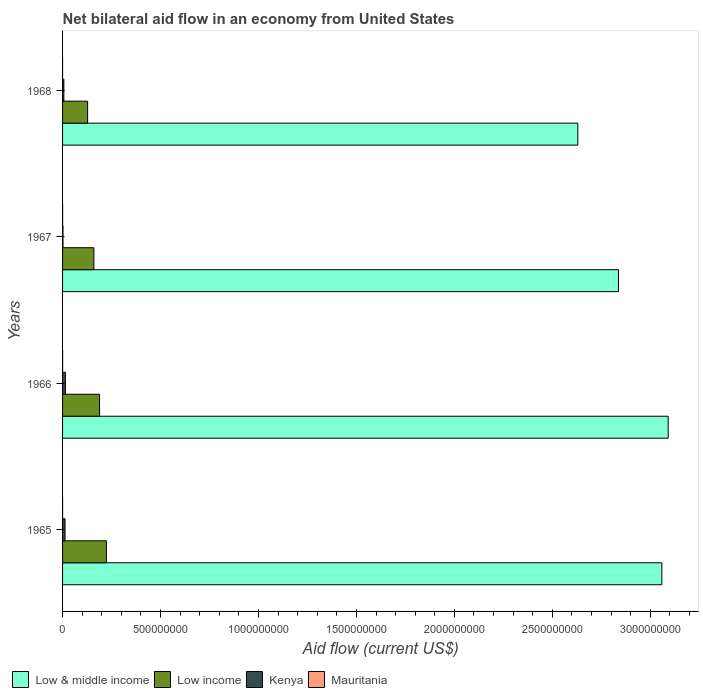Are the number of bars per tick equal to the number of legend labels?
Your answer should be compact. Yes. Are the number of bars on each tick of the Y-axis equal?
Make the answer very short. Yes. How many bars are there on the 2nd tick from the top?
Offer a very short reply. 4. What is the label of the 2nd group of bars from the top?
Your answer should be very brief. 1967. What is the net bilateral aid flow in Kenya in 1966?
Offer a terse response. 1.45e+07. Across all years, what is the minimum net bilateral aid flow in Low income?
Provide a short and direct response. 1.28e+08. In which year was the net bilateral aid flow in Mauritania maximum?
Offer a very short reply. 1966. In which year was the net bilateral aid flow in Low income minimum?
Your answer should be very brief. 1968. What is the total net bilateral aid flow in Low income in the graph?
Make the answer very short. 7.00e+08. What is the difference between the net bilateral aid flow in Mauritania in 1965 and the net bilateral aid flow in Low & middle income in 1968?
Offer a terse response. -2.63e+09. What is the average net bilateral aid flow in Kenya per year?
Your answer should be very brief. 8.94e+06. In the year 1965, what is the difference between the net bilateral aid flow in Kenya and net bilateral aid flow in Mauritania?
Your answer should be very brief. 1.25e+07. What is the ratio of the net bilateral aid flow in Kenya in 1967 to that in 1968?
Give a very brief answer. 0.32. Is the net bilateral aid flow in Mauritania in 1966 less than that in 1968?
Your response must be concise. No. Is the difference between the net bilateral aid flow in Kenya in 1965 and 1967 greater than the difference between the net bilateral aid flow in Mauritania in 1965 and 1967?
Provide a short and direct response. Yes. What is the difference between the highest and the second highest net bilateral aid flow in Low & middle income?
Your answer should be compact. 3.24e+07. What is the difference between the highest and the lowest net bilateral aid flow in Low & middle income?
Your answer should be very brief. 4.61e+08. Is the sum of the net bilateral aid flow in Low & middle income in 1966 and 1968 greater than the maximum net bilateral aid flow in Kenya across all years?
Your answer should be very brief. Yes. What does the 2nd bar from the top in 1965 represents?
Keep it short and to the point. Kenya. What does the 4th bar from the bottom in 1967 represents?
Offer a very short reply. Mauritania. How many bars are there?
Give a very brief answer. 16. Are all the bars in the graph horizontal?
Give a very brief answer. Yes. Does the graph contain grids?
Your answer should be very brief. No. Where does the legend appear in the graph?
Give a very brief answer. Bottom left. How are the legend labels stacked?
Offer a very short reply. Horizontal. What is the title of the graph?
Provide a succinct answer. Net bilateral aid flow in an economy from United States. Does "Bulgaria" appear as one of the legend labels in the graph?
Provide a succinct answer. No. What is the Aid flow (current US$) of Low & middle income in 1965?
Ensure brevity in your answer.  3.06e+09. What is the Aid flow (current US$) of Low income in 1965?
Offer a terse response. 2.24e+08. What is the Aid flow (current US$) in Kenya in 1965?
Provide a short and direct response. 1.26e+07. What is the Aid flow (current US$) in Mauritania in 1965?
Your response must be concise. 1.30e+05. What is the Aid flow (current US$) of Low & middle income in 1966?
Offer a terse response. 3.09e+09. What is the Aid flow (current US$) in Low income in 1966?
Ensure brevity in your answer.  1.89e+08. What is the Aid flow (current US$) in Kenya in 1966?
Give a very brief answer. 1.45e+07. What is the Aid flow (current US$) of Mauritania in 1966?
Offer a very short reply. 3.40e+05. What is the Aid flow (current US$) of Low & middle income in 1967?
Keep it short and to the point. 2.84e+09. What is the Aid flow (current US$) of Low income in 1967?
Provide a short and direct response. 1.60e+08. What is the Aid flow (current US$) in Kenya in 1967?
Your answer should be very brief. 2.10e+06. What is the Aid flow (current US$) in Mauritania in 1967?
Ensure brevity in your answer.  2.70e+05. What is the Aid flow (current US$) in Low & middle income in 1968?
Provide a succinct answer. 2.63e+09. What is the Aid flow (current US$) in Low income in 1968?
Offer a terse response. 1.28e+08. What is the Aid flow (current US$) of Kenya in 1968?
Offer a very short reply. 6.58e+06. What is the Aid flow (current US$) of Mauritania in 1968?
Offer a terse response. 2.00e+04. Across all years, what is the maximum Aid flow (current US$) of Low & middle income?
Offer a very short reply. 3.09e+09. Across all years, what is the maximum Aid flow (current US$) in Low income?
Make the answer very short. 2.24e+08. Across all years, what is the maximum Aid flow (current US$) of Kenya?
Provide a succinct answer. 1.45e+07. Across all years, what is the maximum Aid flow (current US$) of Mauritania?
Offer a terse response. 3.40e+05. Across all years, what is the minimum Aid flow (current US$) of Low & middle income?
Offer a very short reply. 2.63e+09. Across all years, what is the minimum Aid flow (current US$) in Low income?
Provide a short and direct response. 1.28e+08. Across all years, what is the minimum Aid flow (current US$) in Kenya?
Offer a very short reply. 2.10e+06. What is the total Aid flow (current US$) in Low & middle income in the graph?
Keep it short and to the point. 1.16e+1. What is the total Aid flow (current US$) in Low income in the graph?
Your answer should be compact. 7.00e+08. What is the total Aid flow (current US$) in Kenya in the graph?
Your answer should be very brief. 3.58e+07. What is the total Aid flow (current US$) of Mauritania in the graph?
Give a very brief answer. 7.60e+05. What is the difference between the Aid flow (current US$) in Low & middle income in 1965 and that in 1966?
Ensure brevity in your answer.  -3.24e+07. What is the difference between the Aid flow (current US$) in Low income in 1965 and that in 1966?
Your answer should be very brief. 3.49e+07. What is the difference between the Aid flow (current US$) in Kenya in 1965 and that in 1966?
Offer a terse response. -1.84e+06. What is the difference between the Aid flow (current US$) of Low & middle income in 1965 and that in 1967?
Provide a short and direct response. 2.21e+08. What is the difference between the Aid flow (current US$) of Low income in 1965 and that in 1967?
Offer a terse response. 6.38e+07. What is the difference between the Aid flow (current US$) of Kenya in 1965 and that in 1967?
Ensure brevity in your answer.  1.05e+07. What is the difference between the Aid flow (current US$) of Low & middle income in 1965 and that in 1968?
Ensure brevity in your answer.  4.29e+08. What is the difference between the Aid flow (current US$) of Low income in 1965 and that in 1968?
Give a very brief answer. 9.59e+07. What is the difference between the Aid flow (current US$) of Kenya in 1965 and that in 1968?
Provide a short and direct response. 6.04e+06. What is the difference between the Aid flow (current US$) in Mauritania in 1965 and that in 1968?
Offer a terse response. 1.10e+05. What is the difference between the Aid flow (current US$) of Low & middle income in 1966 and that in 1967?
Offer a very short reply. 2.54e+08. What is the difference between the Aid flow (current US$) in Low income in 1966 and that in 1967?
Offer a terse response. 2.89e+07. What is the difference between the Aid flow (current US$) in Kenya in 1966 and that in 1967?
Give a very brief answer. 1.24e+07. What is the difference between the Aid flow (current US$) in Low & middle income in 1966 and that in 1968?
Offer a very short reply. 4.61e+08. What is the difference between the Aid flow (current US$) in Low income in 1966 and that in 1968?
Give a very brief answer. 6.10e+07. What is the difference between the Aid flow (current US$) of Kenya in 1966 and that in 1968?
Give a very brief answer. 7.88e+06. What is the difference between the Aid flow (current US$) in Mauritania in 1966 and that in 1968?
Give a very brief answer. 3.20e+05. What is the difference between the Aid flow (current US$) in Low & middle income in 1967 and that in 1968?
Give a very brief answer. 2.08e+08. What is the difference between the Aid flow (current US$) in Low income in 1967 and that in 1968?
Keep it short and to the point. 3.21e+07. What is the difference between the Aid flow (current US$) of Kenya in 1967 and that in 1968?
Your answer should be compact. -4.48e+06. What is the difference between the Aid flow (current US$) in Mauritania in 1967 and that in 1968?
Ensure brevity in your answer.  2.50e+05. What is the difference between the Aid flow (current US$) of Low & middle income in 1965 and the Aid flow (current US$) of Low income in 1966?
Your answer should be very brief. 2.87e+09. What is the difference between the Aid flow (current US$) of Low & middle income in 1965 and the Aid flow (current US$) of Kenya in 1966?
Offer a terse response. 3.04e+09. What is the difference between the Aid flow (current US$) of Low & middle income in 1965 and the Aid flow (current US$) of Mauritania in 1966?
Your answer should be very brief. 3.06e+09. What is the difference between the Aid flow (current US$) in Low income in 1965 and the Aid flow (current US$) in Kenya in 1966?
Provide a succinct answer. 2.09e+08. What is the difference between the Aid flow (current US$) of Low income in 1965 and the Aid flow (current US$) of Mauritania in 1966?
Offer a terse response. 2.23e+08. What is the difference between the Aid flow (current US$) in Kenya in 1965 and the Aid flow (current US$) in Mauritania in 1966?
Keep it short and to the point. 1.23e+07. What is the difference between the Aid flow (current US$) in Low & middle income in 1965 and the Aid flow (current US$) in Low income in 1967?
Your response must be concise. 2.90e+09. What is the difference between the Aid flow (current US$) of Low & middle income in 1965 and the Aid flow (current US$) of Kenya in 1967?
Provide a succinct answer. 3.06e+09. What is the difference between the Aid flow (current US$) of Low & middle income in 1965 and the Aid flow (current US$) of Mauritania in 1967?
Offer a terse response. 3.06e+09. What is the difference between the Aid flow (current US$) in Low income in 1965 and the Aid flow (current US$) in Kenya in 1967?
Ensure brevity in your answer.  2.22e+08. What is the difference between the Aid flow (current US$) of Low income in 1965 and the Aid flow (current US$) of Mauritania in 1967?
Make the answer very short. 2.24e+08. What is the difference between the Aid flow (current US$) in Kenya in 1965 and the Aid flow (current US$) in Mauritania in 1967?
Keep it short and to the point. 1.24e+07. What is the difference between the Aid flow (current US$) of Low & middle income in 1965 and the Aid flow (current US$) of Low income in 1968?
Provide a short and direct response. 2.93e+09. What is the difference between the Aid flow (current US$) of Low & middle income in 1965 and the Aid flow (current US$) of Kenya in 1968?
Keep it short and to the point. 3.05e+09. What is the difference between the Aid flow (current US$) of Low & middle income in 1965 and the Aid flow (current US$) of Mauritania in 1968?
Provide a short and direct response. 3.06e+09. What is the difference between the Aid flow (current US$) of Low income in 1965 and the Aid flow (current US$) of Kenya in 1968?
Give a very brief answer. 2.17e+08. What is the difference between the Aid flow (current US$) in Low income in 1965 and the Aid flow (current US$) in Mauritania in 1968?
Keep it short and to the point. 2.24e+08. What is the difference between the Aid flow (current US$) in Kenya in 1965 and the Aid flow (current US$) in Mauritania in 1968?
Your answer should be compact. 1.26e+07. What is the difference between the Aid flow (current US$) in Low & middle income in 1966 and the Aid flow (current US$) in Low income in 1967?
Keep it short and to the point. 2.93e+09. What is the difference between the Aid flow (current US$) of Low & middle income in 1966 and the Aid flow (current US$) of Kenya in 1967?
Offer a very short reply. 3.09e+09. What is the difference between the Aid flow (current US$) in Low & middle income in 1966 and the Aid flow (current US$) in Mauritania in 1967?
Give a very brief answer. 3.09e+09. What is the difference between the Aid flow (current US$) of Low income in 1966 and the Aid flow (current US$) of Kenya in 1967?
Your answer should be very brief. 1.87e+08. What is the difference between the Aid flow (current US$) in Low income in 1966 and the Aid flow (current US$) in Mauritania in 1967?
Provide a succinct answer. 1.89e+08. What is the difference between the Aid flow (current US$) of Kenya in 1966 and the Aid flow (current US$) of Mauritania in 1967?
Your response must be concise. 1.42e+07. What is the difference between the Aid flow (current US$) of Low & middle income in 1966 and the Aid flow (current US$) of Low income in 1968?
Offer a terse response. 2.96e+09. What is the difference between the Aid flow (current US$) of Low & middle income in 1966 and the Aid flow (current US$) of Kenya in 1968?
Offer a very short reply. 3.08e+09. What is the difference between the Aid flow (current US$) of Low & middle income in 1966 and the Aid flow (current US$) of Mauritania in 1968?
Ensure brevity in your answer.  3.09e+09. What is the difference between the Aid flow (current US$) of Low income in 1966 and the Aid flow (current US$) of Kenya in 1968?
Provide a succinct answer. 1.82e+08. What is the difference between the Aid flow (current US$) in Low income in 1966 and the Aid flow (current US$) in Mauritania in 1968?
Offer a very short reply. 1.89e+08. What is the difference between the Aid flow (current US$) in Kenya in 1966 and the Aid flow (current US$) in Mauritania in 1968?
Your response must be concise. 1.44e+07. What is the difference between the Aid flow (current US$) in Low & middle income in 1967 and the Aid flow (current US$) in Low income in 1968?
Ensure brevity in your answer.  2.71e+09. What is the difference between the Aid flow (current US$) of Low & middle income in 1967 and the Aid flow (current US$) of Kenya in 1968?
Ensure brevity in your answer.  2.83e+09. What is the difference between the Aid flow (current US$) of Low & middle income in 1967 and the Aid flow (current US$) of Mauritania in 1968?
Provide a short and direct response. 2.84e+09. What is the difference between the Aid flow (current US$) in Low income in 1967 and the Aid flow (current US$) in Kenya in 1968?
Offer a very short reply. 1.53e+08. What is the difference between the Aid flow (current US$) of Low income in 1967 and the Aid flow (current US$) of Mauritania in 1968?
Ensure brevity in your answer.  1.60e+08. What is the difference between the Aid flow (current US$) of Kenya in 1967 and the Aid flow (current US$) of Mauritania in 1968?
Your answer should be very brief. 2.08e+06. What is the average Aid flow (current US$) of Low & middle income per year?
Keep it short and to the point. 2.90e+09. What is the average Aid flow (current US$) in Low income per year?
Your response must be concise. 1.75e+08. What is the average Aid flow (current US$) in Kenya per year?
Provide a short and direct response. 8.94e+06. In the year 1965, what is the difference between the Aid flow (current US$) of Low & middle income and Aid flow (current US$) of Low income?
Your answer should be compact. 2.84e+09. In the year 1965, what is the difference between the Aid flow (current US$) in Low & middle income and Aid flow (current US$) in Kenya?
Provide a succinct answer. 3.05e+09. In the year 1965, what is the difference between the Aid flow (current US$) in Low & middle income and Aid flow (current US$) in Mauritania?
Your answer should be compact. 3.06e+09. In the year 1965, what is the difference between the Aid flow (current US$) in Low income and Aid flow (current US$) in Kenya?
Ensure brevity in your answer.  2.11e+08. In the year 1965, what is the difference between the Aid flow (current US$) of Low income and Aid flow (current US$) of Mauritania?
Ensure brevity in your answer.  2.24e+08. In the year 1965, what is the difference between the Aid flow (current US$) in Kenya and Aid flow (current US$) in Mauritania?
Give a very brief answer. 1.25e+07. In the year 1966, what is the difference between the Aid flow (current US$) of Low & middle income and Aid flow (current US$) of Low income?
Keep it short and to the point. 2.90e+09. In the year 1966, what is the difference between the Aid flow (current US$) in Low & middle income and Aid flow (current US$) in Kenya?
Offer a very short reply. 3.08e+09. In the year 1966, what is the difference between the Aid flow (current US$) in Low & middle income and Aid flow (current US$) in Mauritania?
Make the answer very short. 3.09e+09. In the year 1966, what is the difference between the Aid flow (current US$) of Low income and Aid flow (current US$) of Kenya?
Keep it short and to the point. 1.74e+08. In the year 1966, what is the difference between the Aid flow (current US$) of Low income and Aid flow (current US$) of Mauritania?
Your answer should be very brief. 1.89e+08. In the year 1966, what is the difference between the Aid flow (current US$) in Kenya and Aid flow (current US$) in Mauritania?
Make the answer very short. 1.41e+07. In the year 1967, what is the difference between the Aid flow (current US$) of Low & middle income and Aid flow (current US$) of Low income?
Provide a succinct answer. 2.68e+09. In the year 1967, what is the difference between the Aid flow (current US$) in Low & middle income and Aid flow (current US$) in Kenya?
Your response must be concise. 2.84e+09. In the year 1967, what is the difference between the Aid flow (current US$) of Low & middle income and Aid flow (current US$) of Mauritania?
Ensure brevity in your answer.  2.84e+09. In the year 1967, what is the difference between the Aid flow (current US$) of Low income and Aid flow (current US$) of Kenya?
Offer a terse response. 1.58e+08. In the year 1967, what is the difference between the Aid flow (current US$) of Low income and Aid flow (current US$) of Mauritania?
Provide a short and direct response. 1.60e+08. In the year 1967, what is the difference between the Aid flow (current US$) of Kenya and Aid flow (current US$) of Mauritania?
Provide a short and direct response. 1.83e+06. In the year 1968, what is the difference between the Aid flow (current US$) of Low & middle income and Aid flow (current US$) of Low income?
Offer a very short reply. 2.50e+09. In the year 1968, what is the difference between the Aid flow (current US$) of Low & middle income and Aid flow (current US$) of Kenya?
Provide a succinct answer. 2.62e+09. In the year 1968, what is the difference between the Aid flow (current US$) of Low & middle income and Aid flow (current US$) of Mauritania?
Provide a succinct answer. 2.63e+09. In the year 1968, what is the difference between the Aid flow (current US$) in Low income and Aid flow (current US$) in Kenya?
Provide a succinct answer. 1.21e+08. In the year 1968, what is the difference between the Aid flow (current US$) of Low income and Aid flow (current US$) of Mauritania?
Your answer should be compact. 1.28e+08. In the year 1968, what is the difference between the Aid flow (current US$) of Kenya and Aid flow (current US$) of Mauritania?
Your answer should be very brief. 6.56e+06. What is the ratio of the Aid flow (current US$) in Low & middle income in 1965 to that in 1966?
Offer a very short reply. 0.99. What is the ratio of the Aid flow (current US$) of Low income in 1965 to that in 1966?
Provide a succinct answer. 1.18. What is the ratio of the Aid flow (current US$) of Kenya in 1965 to that in 1966?
Keep it short and to the point. 0.87. What is the ratio of the Aid flow (current US$) in Mauritania in 1965 to that in 1966?
Offer a terse response. 0.38. What is the ratio of the Aid flow (current US$) of Low & middle income in 1965 to that in 1967?
Offer a very short reply. 1.08. What is the ratio of the Aid flow (current US$) of Low income in 1965 to that in 1967?
Make the answer very short. 1.4. What is the ratio of the Aid flow (current US$) of Kenya in 1965 to that in 1967?
Ensure brevity in your answer.  6.01. What is the ratio of the Aid flow (current US$) in Mauritania in 1965 to that in 1967?
Your response must be concise. 0.48. What is the ratio of the Aid flow (current US$) in Low & middle income in 1965 to that in 1968?
Make the answer very short. 1.16. What is the ratio of the Aid flow (current US$) in Low income in 1965 to that in 1968?
Provide a short and direct response. 1.75. What is the ratio of the Aid flow (current US$) of Kenya in 1965 to that in 1968?
Offer a terse response. 1.92. What is the ratio of the Aid flow (current US$) of Mauritania in 1965 to that in 1968?
Your response must be concise. 6.5. What is the ratio of the Aid flow (current US$) of Low & middle income in 1966 to that in 1967?
Offer a terse response. 1.09. What is the ratio of the Aid flow (current US$) in Low income in 1966 to that in 1967?
Offer a terse response. 1.18. What is the ratio of the Aid flow (current US$) of Kenya in 1966 to that in 1967?
Your response must be concise. 6.89. What is the ratio of the Aid flow (current US$) of Mauritania in 1966 to that in 1967?
Offer a very short reply. 1.26. What is the ratio of the Aid flow (current US$) in Low & middle income in 1966 to that in 1968?
Offer a terse response. 1.18. What is the ratio of the Aid flow (current US$) in Low income in 1966 to that in 1968?
Your answer should be compact. 1.48. What is the ratio of the Aid flow (current US$) in Kenya in 1966 to that in 1968?
Offer a terse response. 2.2. What is the ratio of the Aid flow (current US$) in Mauritania in 1966 to that in 1968?
Ensure brevity in your answer.  17. What is the ratio of the Aid flow (current US$) in Low & middle income in 1967 to that in 1968?
Your response must be concise. 1.08. What is the ratio of the Aid flow (current US$) in Low income in 1967 to that in 1968?
Offer a terse response. 1.25. What is the ratio of the Aid flow (current US$) of Kenya in 1967 to that in 1968?
Provide a succinct answer. 0.32. What is the difference between the highest and the second highest Aid flow (current US$) of Low & middle income?
Make the answer very short. 3.24e+07. What is the difference between the highest and the second highest Aid flow (current US$) in Low income?
Give a very brief answer. 3.49e+07. What is the difference between the highest and the second highest Aid flow (current US$) of Kenya?
Your answer should be very brief. 1.84e+06. What is the difference between the highest and the lowest Aid flow (current US$) in Low & middle income?
Make the answer very short. 4.61e+08. What is the difference between the highest and the lowest Aid flow (current US$) in Low income?
Make the answer very short. 9.59e+07. What is the difference between the highest and the lowest Aid flow (current US$) in Kenya?
Make the answer very short. 1.24e+07. What is the difference between the highest and the lowest Aid flow (current US$) of Mauritania?
Provide a short and direct response. 3.20e+05. 